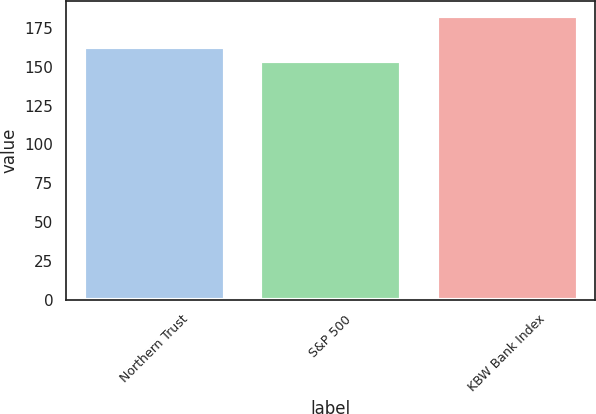Convert chart. <chart><loc_0><loc_0><loc_500><loc_500><bar_chart><fcel>Northern Trust<fcel>S&P 500<fcel>KBW Bank Index<nl><fcel>163<fcel>154<fcel>183<nl></chart> 